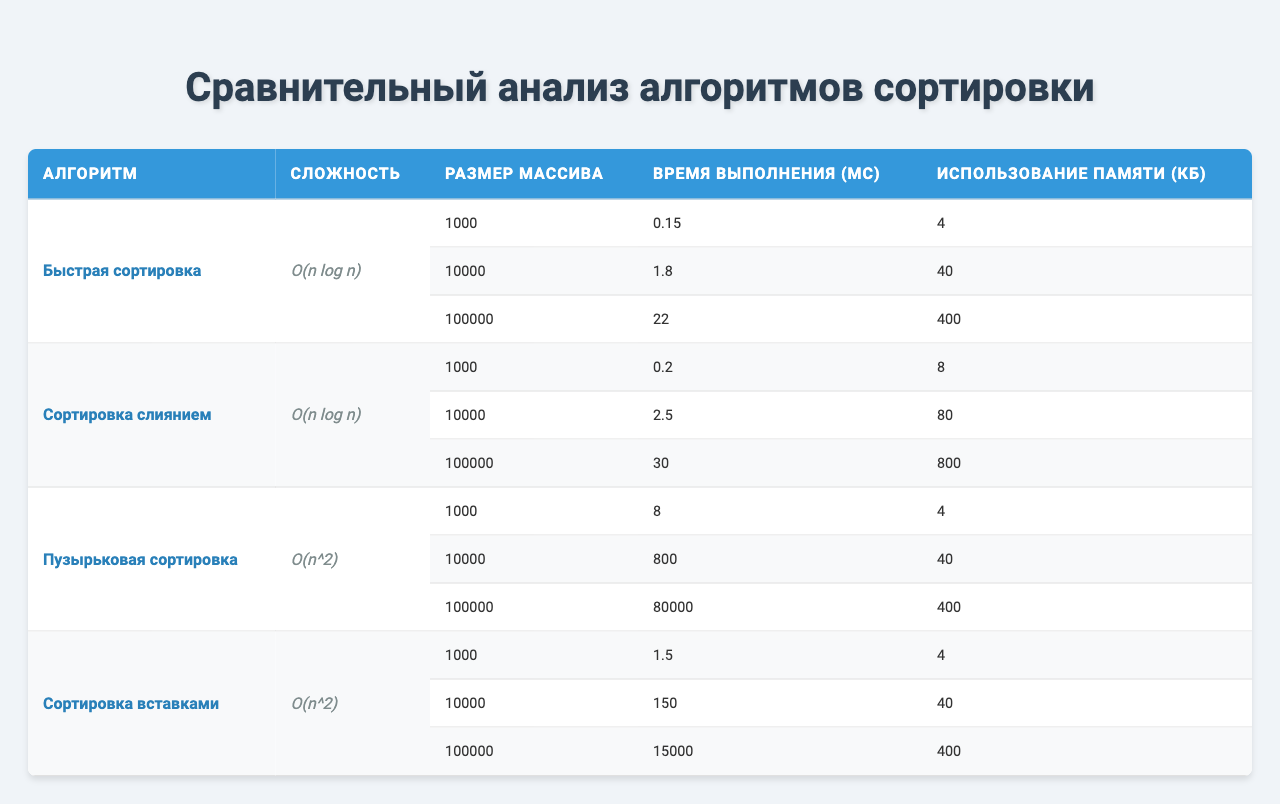Какой алгоритм сортировки имеет наименьшую сложность? Быстрая сортировка и сортировка слиянием имеют сложность O(n log n), это наименьшая сложность среди представленных алгоритмов.
Answer: Быстрая сортировка и сортировка слиянием Какое время выполнения у пузырьковой сортировки для массива размером 10000? Время выполнения пузырьковой сортировки для массива размером 10000 указано в таблице как 800 мс.
Answer: 800 мс Сколько памяти использует сортировка вставками для массива на 100000 элементов? В таблице указано, что сортировка вставками для массива размером 100000 использует 400 КБ памяти.
Answer: 400 КБ Какова средняя сложность всех приведённых алгоритмов сортировки? Средняя сложность рассчитывается как: (O(n log n) + O(n log n) + O(n^2) + O(n^2)) / 4. С учетом сложности алгоритмов два из них имеют меньшую сложность, поэтому в общем случае можно сказать, что средняя сложность не превышает O(n log n).
Answer: O(n log n) Какое наименьшее время выполнения у всех алгоритмов сортировки для массива размером 1000? Наименьшее время выполнения для массива размером 1000 видно в таблице и составляет 0.15 мс, что соответствует быстрой сортировке.
Answer: 0.15 мс Каков общий объём памяти, используемый всеми алгоритмами сортировки для массива размером 1000? Суммируем использование памяти всех алгоритмов для массива размером 1000: 4 КБ (быстрая сортировка) + 8 КБ (сортировка слиянием) + 4 КБ (пузырьковая сортировка) + 4 КБ (сортировка вставками) = 20 КБ.
Answer: 20 КБ Какой алгоритм сортировки требует больше всего памяти для массива размером 100000? Сравнивая значения в таблице, сортировка слиянием требует 800 КБ памяти, это больше, чем у других алгоритмов для массива этого размера.
Answer: Сортировка слиянием Какое время выполнения у быстрой сортировки для массива размером 100000 по сравнению с сортировкой вставками? Время выполнения быстрой сортировки для массива размером 100000 составляет 22 мс, а для сортировки вставками - 15000 мс. Быстрая сортировка значительно быстрее по времени выполнения.
Answer: Быстрая сортировка быстрее Какое соотношение времени выполнения пузырьковой сортировки и сортировки слиянием для массива размером 10000? Время выполнения пузырьковой сортировки - 800 мс, а сортировки слиянием - 2.5 мс. Соотношение 800/2.5 = 320. Пузырьковая сортировка в 320 раз медленнее.
Answer: 320 Существует ли алгоритм, у которого использование памяти увеличивается на 1 КБ при увеличении размера массива с 1000 до 10000? Проверяя таблицу, видим, что увеличение использования памяти с 4 КБ (1000) до 40 КБ (10000) не соответствует увеличению на 1 КБ, поэтому это утверждение неверно.
Answer: Нет 